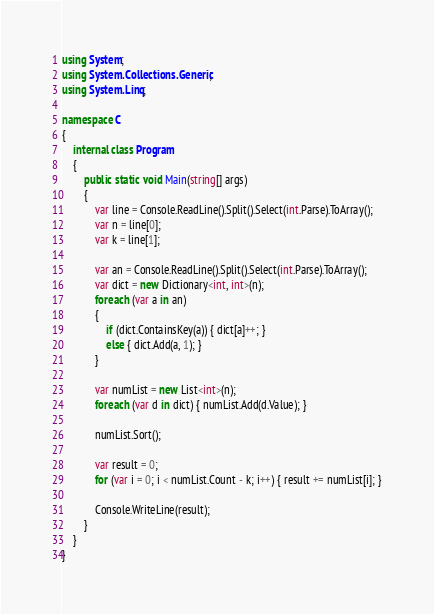Convert code to text. <code><loc_0><loc_0><loc_500><loc_500><_C#_>using System;
using System.Collections.Generic;
using System.Linq;

namespace C
{
	internal class Program
	{
		public static void Main(string[] args)
		{
			var line = Console.ReadLine().Split().Select(int.Parse).ToArray();
			var n = line[0];
			var k = line[1];

			var an = Console.ReadLine().Split().Select(int.Parse).ToArray();
			var dict = new Dictionary<int, int>(n);
			foreach (var a in an)
			{
				if (dict.ContainsKey(a)) { dict[a]++; }
				else { dict.Add(a, 1); }
			}

			var numList = new List<int>(n);
			foreach (var d in dict) { numList.Add(d.Value); }

			numList.Sort();

			var result = 0;
			for (var i = 0; i < numList.Count - k; i++) { result += numList[i]; }

			Console.WriteLine(result);
		}
	}
}</code> 